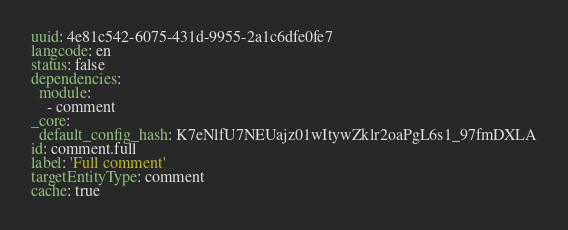Convert code to text. <code><loc_0><loc_0><loc_500><loc_500><_YAML_>uuid: 4e81c542-6075-431d-9955-2a1c6dfe0fe7
langcode: en
status: false
dependencies:
  module:
    - comment
_core:
  default_config_hash: K7eNlfU7NEUajz01wItywZklr2oaPgL6s1_97fmDXLA
id: comment.full
label: 'Full comment'
targetEntityType: comment
cache: true
</code> 